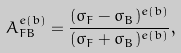<formula> <loc_0><loc_0><loc_500><loc_500>A _ { F B } ^ { e ( b ) } = \frac { ( \sigma _ { F } - \sigma _ { B } ) ^ { e ( b ) } } { ( \sigma _ { F } + \sigma _ { B } ) ^ { e ( b ) } } ,</formula> 